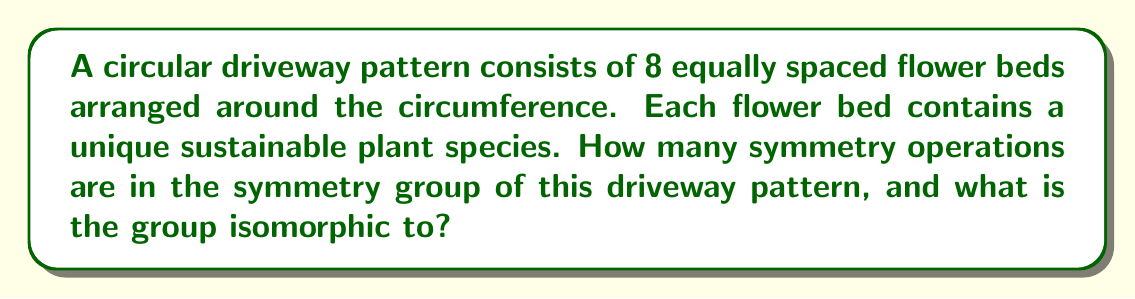What is the answer to this math problem? To determine the symmetry group of this circular driveway pattern, we need to consider all possible symmetry operations that leave the pattern unchanged. Let's approach this step-by-step:

1) Rotational symmetry:
   The pattern has 8 equally spaced elements, so it has 8-fold rotational symmetry.
   Rotations by multiples of 45° (360°/8) will leave the pattern unchanged.
   There are 8 such rotations: 0°, 45°, 90°, 135°, 180°, 225°, 270°, 315°

2) Reflection symmetry:
   There are 8 lines of reflection:
   - 4 passing through opposite flower beds
   - 4 passing between adjacent flower beds

3) Total number of symmetry operations:
   8 rotations + 8 reflections = 16 symmetry operations

4) Group structure:
   This group of 16 elements is known as the dihedral group of order 16, denoted as $D_8$ or $D_{16}$ (depending on the notation system).

5) Group properties:
   - It's non-abelian (rotations and reflections don't always commute)
   - It has 16 elements
   - Its order is $2n$ where $n$ is the number of sides (in this case, $n=8$)

6) Isomorphism:
   This group is isomorphic to the dihedral group $D_8$ (or $D_{16}$), which is the group of symmetries of a regular octagon.

The symmetry group can be generated by two elements:
- $r$: rotation by 45°
- $s$: reflection about a fixed axis

With the relations:
$$r^8 = e$$ (identity after 8 rotations)
$$s^2 = e$$ (two reflections return to identity)
$$(rs)^2 = e$$ (rotation followed by reflection, twice, returns to identity)

This completely defines the group structure.
Answer: The symmetry group of the circular driveway pattern has 16 elements and is isomorphic to the dihedral group $D_8$ (or $D_{16}$). 